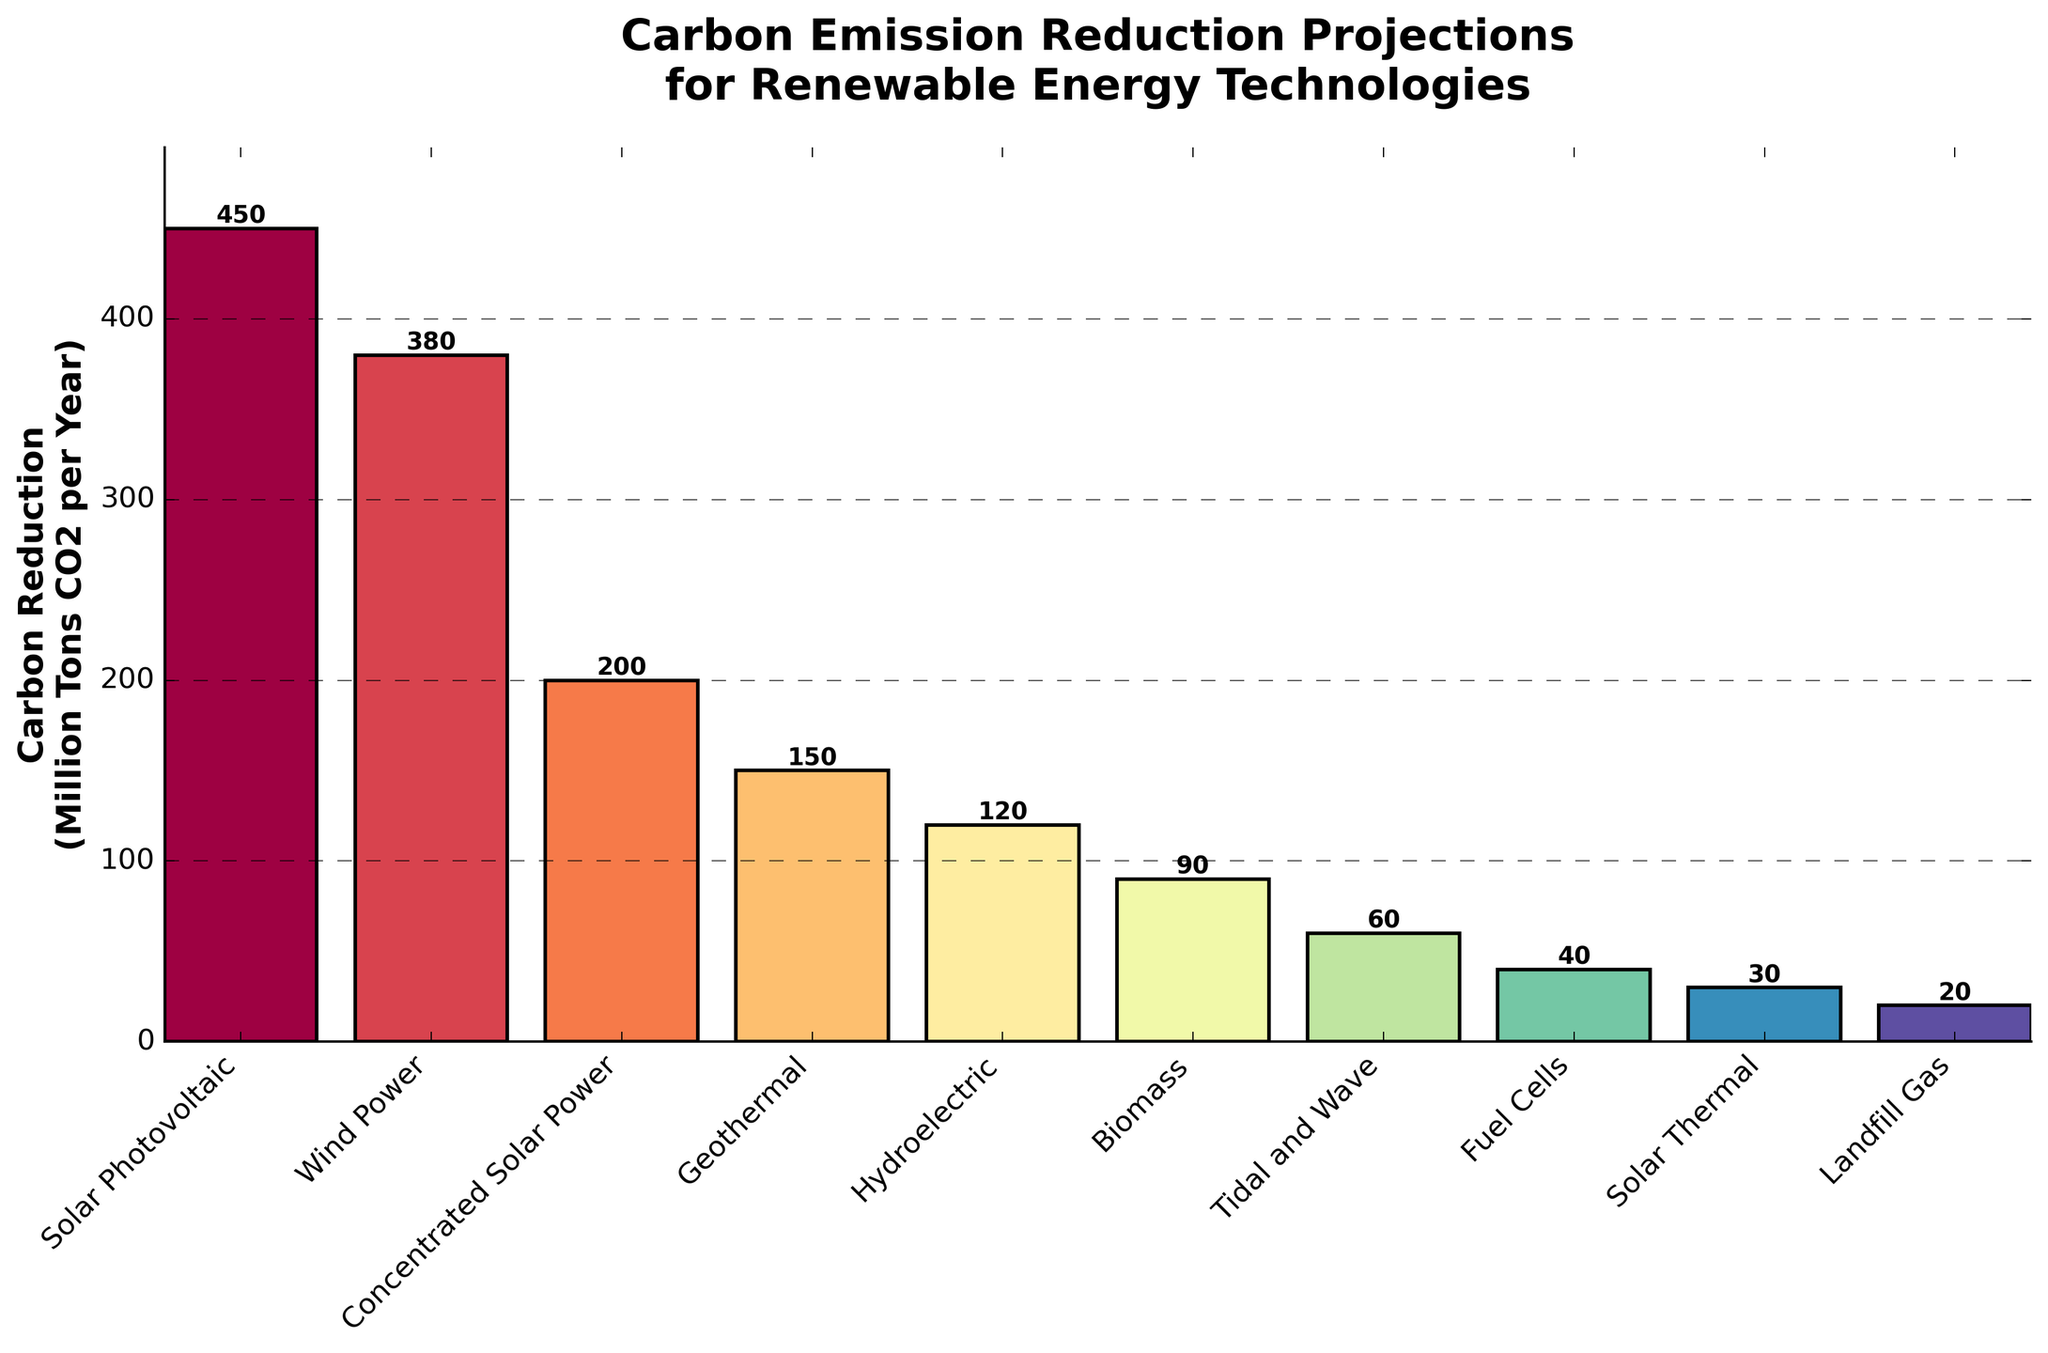What is the total carbon reduction from Solar Photovoltaic and Wind Power combined? Add the carbon reduction values for Solar Photovoltaic (450) and Wind Power (380): 450 + 380 = 830
Answer: 830 Which technology achieves the highest carbon emission reduction? Examine the heights of the bars; the tallest bar represents Solar Photovoltaic at 450 million tons CO2 per year
Answer: Solar Photovoltaic How much more carbon reduction does Geothermal provide compared to Landfill Gas? Subtract the carbon reduction of Landfill Gas (20) from Geothermal (150): 150 - 20 = 130
Answer: 130 Rank the top three technologies by carbon reduction. Order the technologies by the height of their bars from highest to lowest: 1. Solar Photovoltaic (450), 2. Wind Power (380), 3. Concentrated Solar Power (200)
Answer: Solar Photovoltaic, Wind Power, Concentrated Solar Power Which technology has a lower carbon reduction, Biomass or Tidal and Wave? Compare the heights of the bars for Biomass (90) and Tidal and Wave (60): Tidal and Wave has a lower carbon reduction
Answer: Tidal and Wave What is the average carbon reduction for all technologies? Sum all reductions and divide by number of technologies: (450 + 380 + 200 + 150 + 120 + 90 + 60 + 40 + 30 + 20) / 10 = 1540 / 10 = 154
Answer: 154 Which technology has the smallest carbon reduction and how much is it? Identify the shortest bar; Landfill Gas with a reduction of 20 million tons CO2 per year
Answer: Landfill Gas, 20 How much carbon reduction is achieved by renewable technologies excluding Solar Photovoltaic and Wind Power? Sum reductions of all other technologies: 200 + 150 + 120 + 90 + 60 + 40 + 30 + 20 = 710
Answer: 710 Is the carbon reduction from Fuel Cells greater than that from Solar Thermal? Compare the bars for Fuel Cells (40) and Solar Thermal (30); 40 is greater than 30
Answer: Yes Which technology has a carbon reduction closest to 100 million tons CO2 per year? Compare values close to 100; Biomass at 90 is the closest to 100
Answer: Biomass 